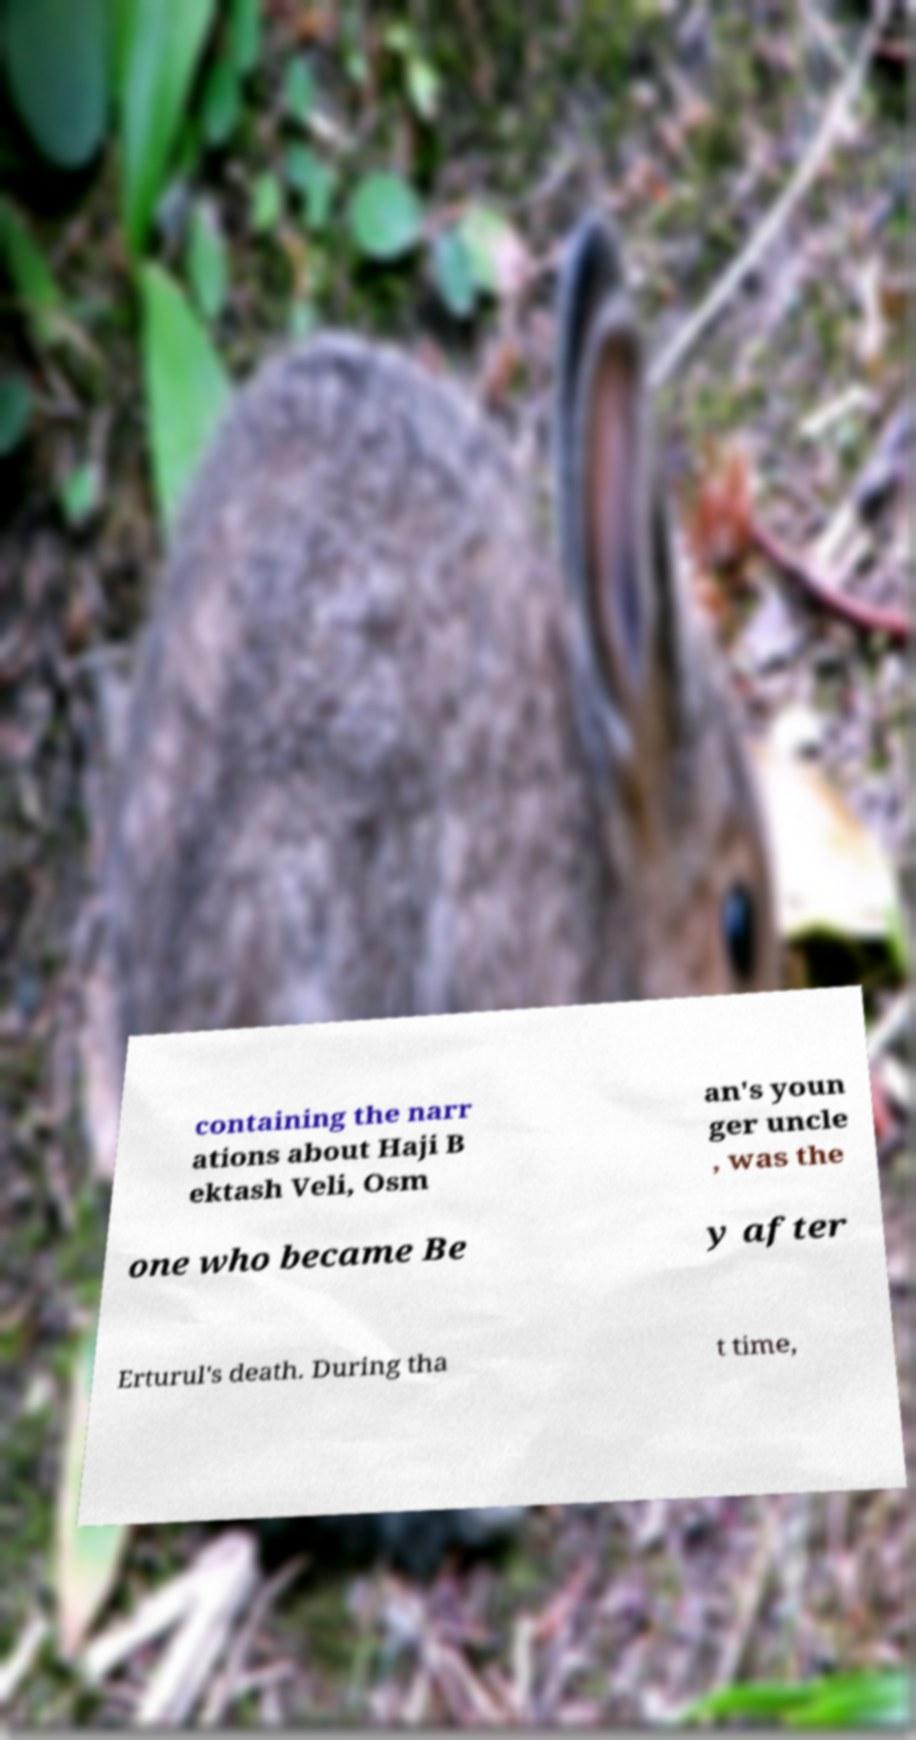Can you read and provide the text displayed in the image?This photo seems to have some interesting text. Can you extract and type it out for me? containing the narr ations about Haji B ektash Veli, Osm an's youn ger uncle , was the one who became Be y after Erturul's death. During tha t time, 